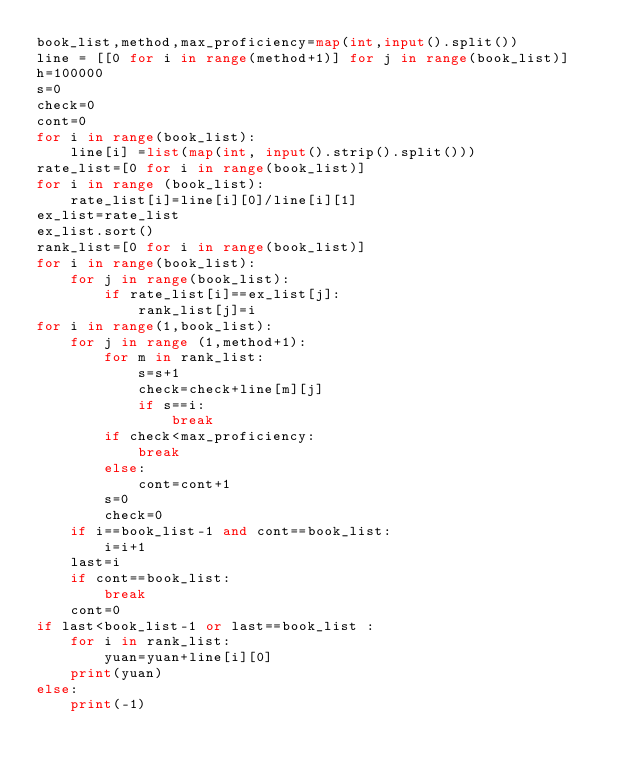<code> <loc_0><loc_0><loc_500><loc_500><_Python_>book_list,method,max_proficiency=map(int,input().split())
line = [[0 for i in range(method+1)] for j in range(book_list)]
h=100000
s=0
check=0
cont=0
for i in range(book_list):
    line[i] =list(map(int, input().strip().split()))
rate_list=[0 for i in range(book_list)]
for i in range (book_list):
    rate_list[i]=line[i][0]/line[i][1]
ex_list=rate_list
ex_list.sort()
rank_list=[0 for i in range(book_list)]
for i in range(book_list):
    for j in range(book_list):
        if rate_list[i]==ex_list[j]:
            rank_list[j]=i
for i in range(1,book_list):
    for j in range (1,method+1):
        for m in rank_list:
            s=s+1
            check=check+line[m][j]
            if s==i:
                break
        if check<max_proficiency:
            break
        else:
            cont=cont+1
        s=0
        check=0
    if i==book_list-1 and cont==book_list:
        i=i+1
    last=i
    if cont==book_list:
        break
    cont=0
if last<book_list-1 or last==book_list :
    for i in rank_list:
        yuan=yuan+line[i][0]
    print(yuan)
else:
    print(-1)</code> 